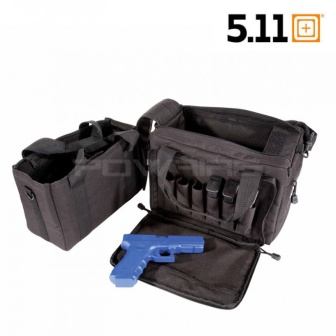Can you describe the main features of this image for me?
 The image presents a **black tactical bag** resting on a **white background**. The bag is designed with **multiple pockets and compartments**, providing ample storage space. One of the compartments is open, revealing a **blue toy gun** inside, indicating the bag's potential use for storing various items. The bag's design suggests it's built for durability and functionality, suitable for tactical use. In the top right corner of the image, the number **"5.11"** is visible, which could be indicative of the bag's brand or model. 